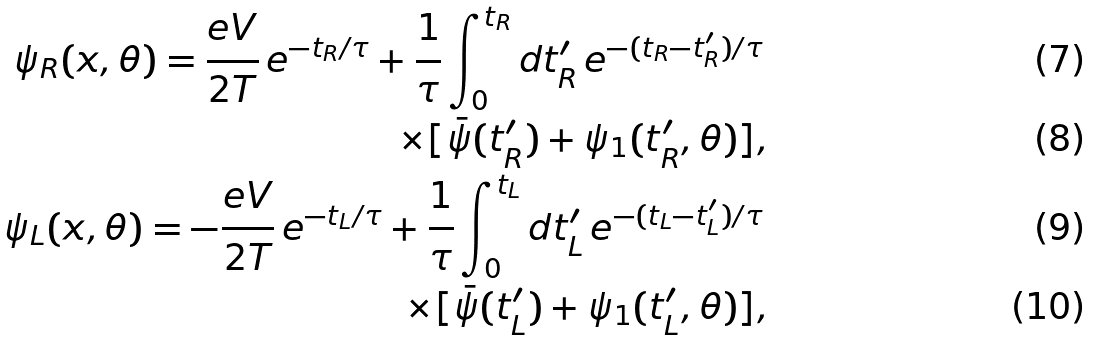<formula> <loc_0><loc_0><loc_500><loc_500>\psi _ { R } ( x , \theta ) = \frac { e V } { 2 T } \, e ^ { - t _ { R } / \tau } + \frac { 1 } { \tau } \int _ { 0 } ^ { t _ { R } } d t _ { R } ^ { \prime } \, e ^ { - ( t _ { R } - t _ { R } ^ { \prime } ) / \tau } \, \\ \times [ \bar { \psi } ( t _ { R } ^ { \prime } ) + \psi _ { 1 } ( t _ { R } ^ { \prime } , \theta ) ] , \\ \psi _ { L } ( x , \theta ) = - \frac { e V } { 2 T } \, e ^ { - t _ { L } / \tau } + \frac { 1 } { \tau } \int _ { 0 } ^ { t _ { L } } d t _ { L } ^ { \prime } \, e ^ { - ( t _ { L } - t _ { L } ^ { \prime } ) / \tau } \, \\ \times [ \bar { \psi } ( t _ { L } ^ { \prime } ) + \psi _ { 1 } ( t _ { L } ^ { \prime } , \theta ) ] ,</formula> 